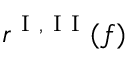Convert formula to latex. <formula><loc_0><loc_0><loc_500><loc_500>r ^ { I , I I } ( f )</formula> 